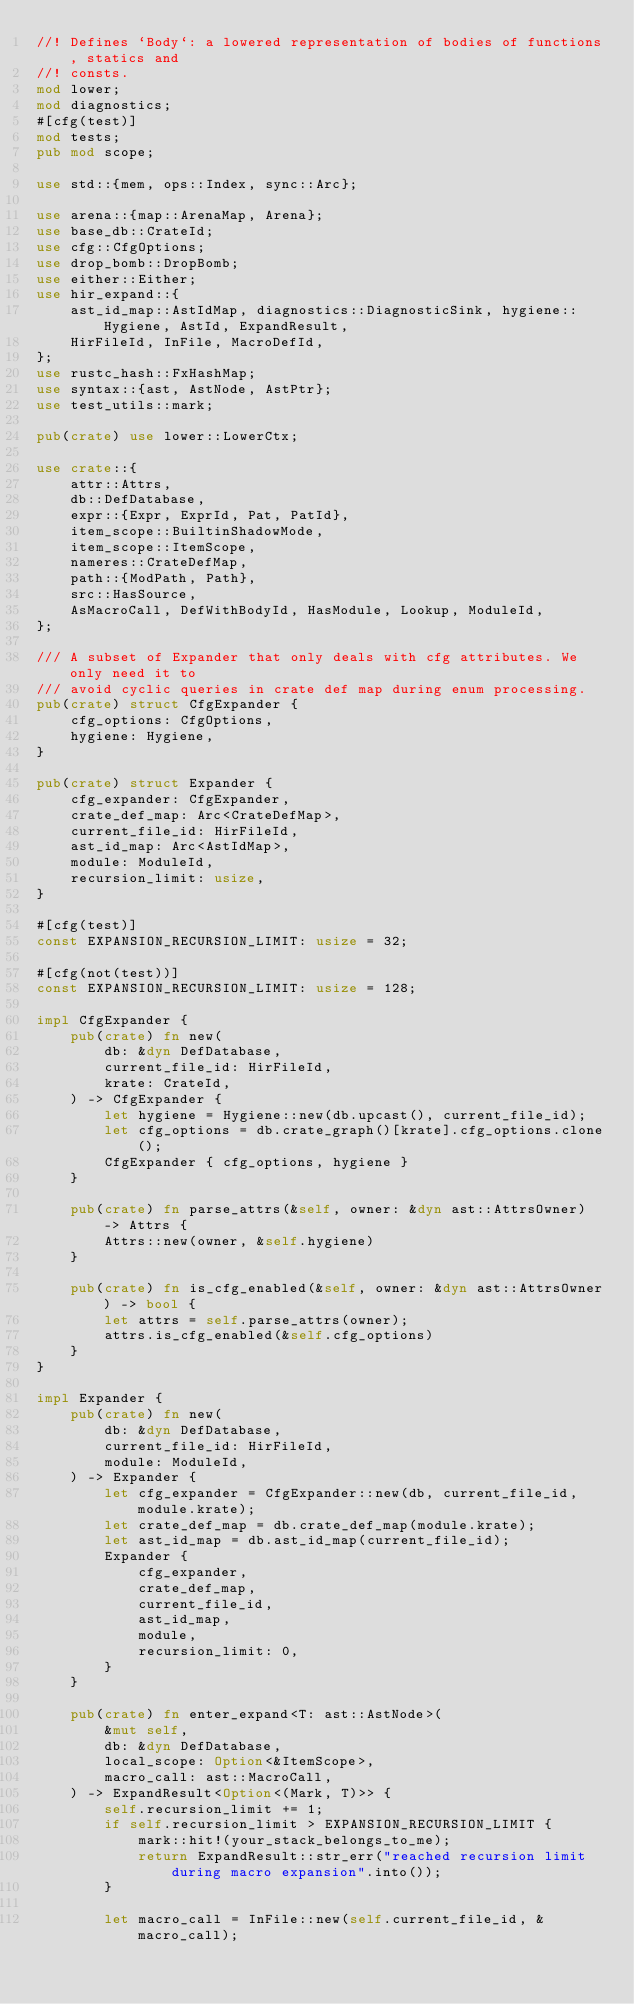<code> <loc_0><loc_0><loc_500><loc_500><_Rust_>//! Defines `Body`: a lowered representation of bodies of functions, statics and
//! consts.
mod lower;
mod diagnostics;
#[cfg(test)]
mod tests;
pub mod scope;

use std::{mem, ops::Index, sync::Arc};

use arena::{map::ArenaMap, Arena};
use base_db::CrateId;
use cfg::CfgOptions;
use drop_bomb::DropBomb;
use either::Either;
use hir_expand::{
    ast_id_map::AstIdMap, diagnostics::DiagnosticSink, hygiene::Hygiene, AstId, ExpandResult,
    HirFileId, InFile, MacroDefId,
};
use rustc_hash::FxHashMap;
use syntax::{ast, AstNode, AstPtr};
use test_utils::mark;

pub(crate) use lower::LowerCtx;

use crate::{
    attr::Attrs,
    db::DefDatabase,
    expr::{Expr, ExprId, Pat, PatId},
    item_scope::BuiltinShadowMode,
    item_scope::ItemScope,
    nameres::CrateDefMap,
    path::{ModPath, Path},
    src::HasSource,
    AsMacroCall, DefWithBodyId, HasModule, Lookup, ModuleId,
};

/// A subset of Expander that only deals with cfg attributes. We only need it to
/// avoid cyclic queries in crate def map during enum processing.
pub(crate) struct CfgExpander {
    cfg_options: CfgOptions,
    hygiene: Hygiene,
}

pub(crate) struct Expander {
    cfg_expander: CfgExpander,
    crate_def_map: Arc<CrateDefMap>,
    current_file_id: HirFileId,
    ast_id_map: Arc<AstIdMap>,
    module: ModuleId,
    recursion_limit: usize,
}

#[cfg(test)]
const EXPANSION_RECURSION_LIMIT: usize = 32;

#[cfg(not(test))]
const EXPANSION_RECURSION_LIMIT: usize = 128;

impl CfgExpander {
    pub(crate) fn new(
        db: &dyn DefDatabase,
        current_file_id: HirFileId,
        krate: CrateId,
    ) -> CfgExpander {
        let hygiene = Hygiene::new(db.upcast(), current_file_id);
        let cfg_options = db.crate_graph()[krate].cfg_options.clone();
        CfgExpander { cfg_options, hygiene }
    }

    pub(crate) fn parse_attrs(&self, owner: &dyn ast::AttrsOwner) -> Attrs {
        Attrs::new(owner, &self.hygiene)
    }

    pub(crate) fn is_cfg_enabled(&self, owner: &dyn ast::AttrsOwner) -> bool {
        let attrs = self.parse_attrs(owner);
        attrs.is_cfg_enabled(&self.cfg_options)
    }
}

impl Expander {
    pub(crate) fn new(
        db: &dyn DefDatabase,
        current_file_id: HirFileId,
        module: ModuleId,
    ) -> Expander {
        let cfg_expander = CfgExpander::new(db, current_file_id, module.krate);
        let crate_def_map = db.crate_def_map(module.krate);
        let ast_id_map = db.ast_id_map(current_file_id);
        Expander {
            cfg_expander,
            crate_def_map,
            current_file_id,
            ast_id_map,
            module,
            recursion_limit: 0,
        }
    }

    pub(crate) fn enter_expand<T: ast::AstNode>(
        &mut self,
        db: &dyn DefDatabase,
        local_scope: Option<&ItemScope>,
        macro_call: ast::MacroCall,
    ) -> ExpandResult<Option<(Mark, T)>> {
        self.recursion_limit += 1;
        if self.recursion_limit > EXPANSION_RECURSION_LIMIT {
            mark::hit!(your_stack_belongs_to_me);
            return ExpandResult::str_err("reached recursion limit during macro expansion".into());
        }

        let macro_call = InFile::new(self.current_file_id, &macro_call);
</code> 